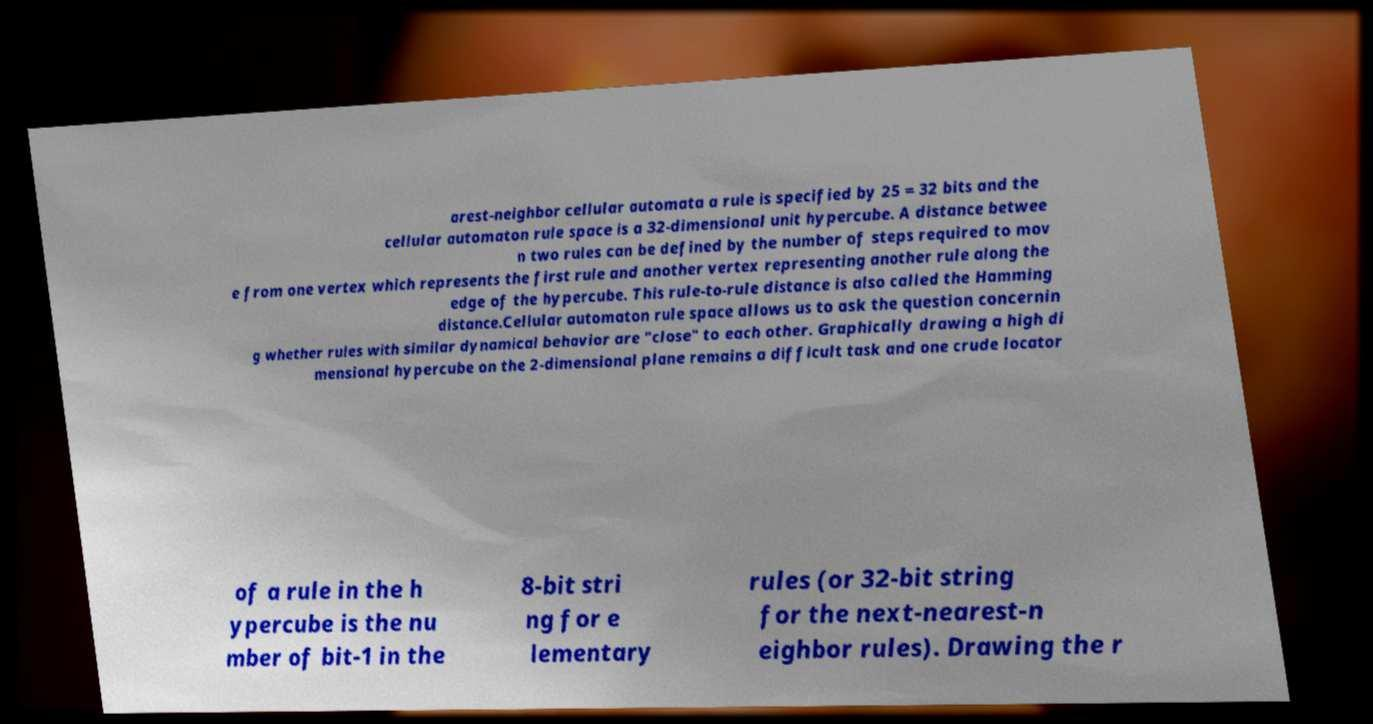For documentation purposes, I need the text within this image transcribed. Could you provide that? arest-neighbor cellular automata a rule is specified by 25 = 32 bits and the cellular automaton rule space is a 32-dimensional unit hypercube. A distance betwee n two rules can be defined by the number of steps required to mov e from one vertex which represents the first rule and another vertex representing another rule along the edge of the hypercube. This rule-to-rule distance is also called the Hamming distance.Cellular automaton rule space allows us to ask the question concernin g whether rules with similar dynamical behavior are "close" to each other. Graphically drawing a high di mensional hypercube on the 2-dimensional plane remains a difficult task and one crude locator of a rule in the h ypercube is the nu mber of bit-1 in the 8-bit stri ng for e lementary rules (or 32-bit string for the next-nearest-n eighbor rules). Drawing the r 